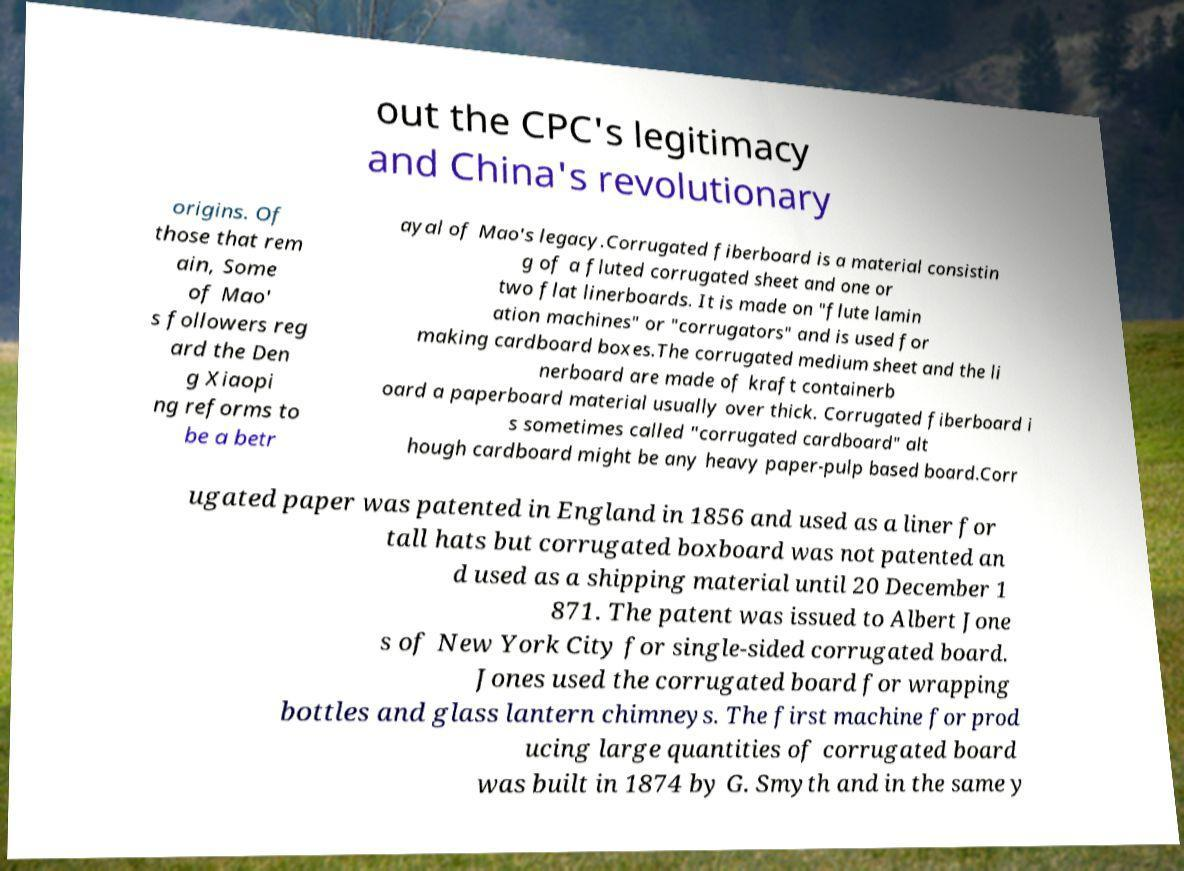Could you assist in decoding the text presented in this image and type it out clearly? out the CPC's legitimacy and China's revolutionary origins. Of those that rem ain, Some of Mao' s followers reg ard the Den g Xiaopi ng reforms to be a betr ayal of Mao's legacy.Corrugated fiberboard is a material consistin g of a fluted corrugated sheet and one or two flat linerboards. It is made on "flute lamin ation machines" or "corrugators" and is used for making cardboard boxes.The corrugated medium sheet and the li nerboard are made of kraft containerb oard a paperboard material usually over thick. Corrugated fiberboard i s sometimes called "corrugated cardboard" alt hough cardboard might be any heavy paper-pulp based board.Corr ugated paper was patented in England in 1856 and used as a liner for tall hats but corrugated boxboard was not patented an d used as a shipping material until 20 December 1 871. The patent was issued to Albert Jone s of New York City for single-sided corrugated board. Jones used the corrugated board for wrapping bottles and glass lantern chimneys. The first machine for prod ucing large quantities of corrugated board was built in 1874 by G. Smyth and in the same y 